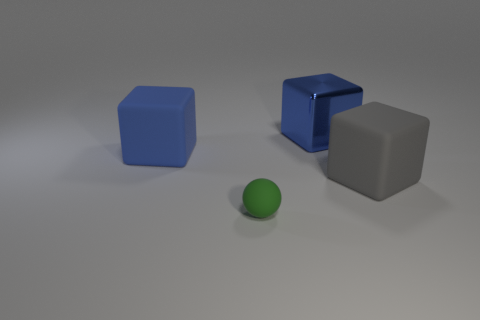Subtract all large blue blocks. How many blocks are left? 1 Add 4 small yellow matte cylinders. How many objects exist? 8 Subtract all spheres. How many objects are left? 3 Subtract 1 blocks. How many blocks are left? 2 Subtract all blue cubes. How many cubes are left? 1 Add 1 tiny green matte objects. How many tiny green matte objects are left? 2 Add 1 big gray matte blocks. How many big gray matte blocks exist? 2 Subtract 1 blue blocks. How many objects are left? 3 Subtract all green blocks. Subtract all blue balls. How many blocks are left? 3 Subtract all red cylinders. How many yellow blocks are left? 0 